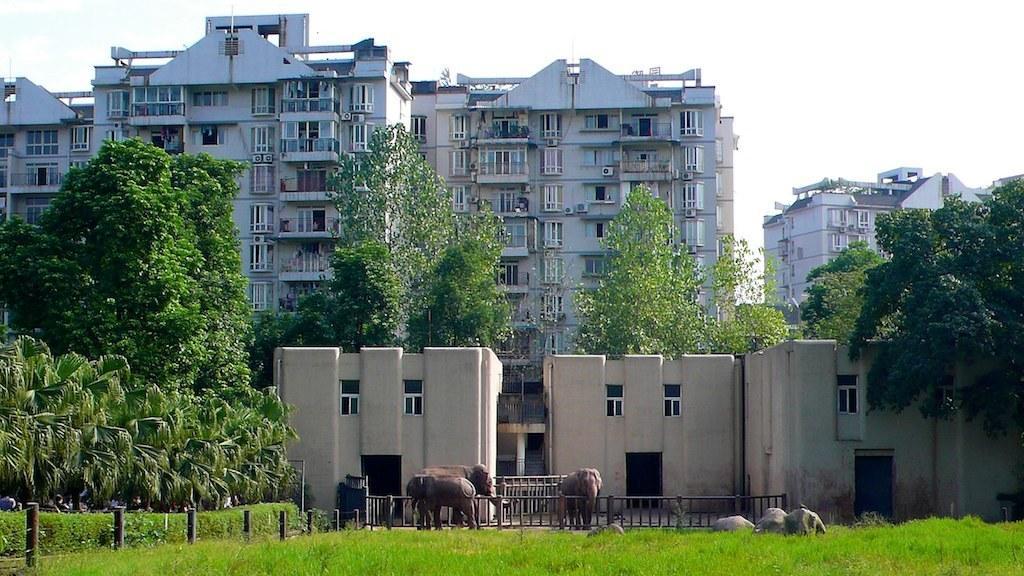Describe this image in one or two sentences. In this picture there are three elephants standing and there is fence around them and there are buildings and trees in the background. 